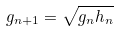Convert formula to latex. <formula><loc_0><loc_0><loc_500><loc_500>g _ { n + 1 } = \sqrt { g _ { n } h _ { n } }</formula> 